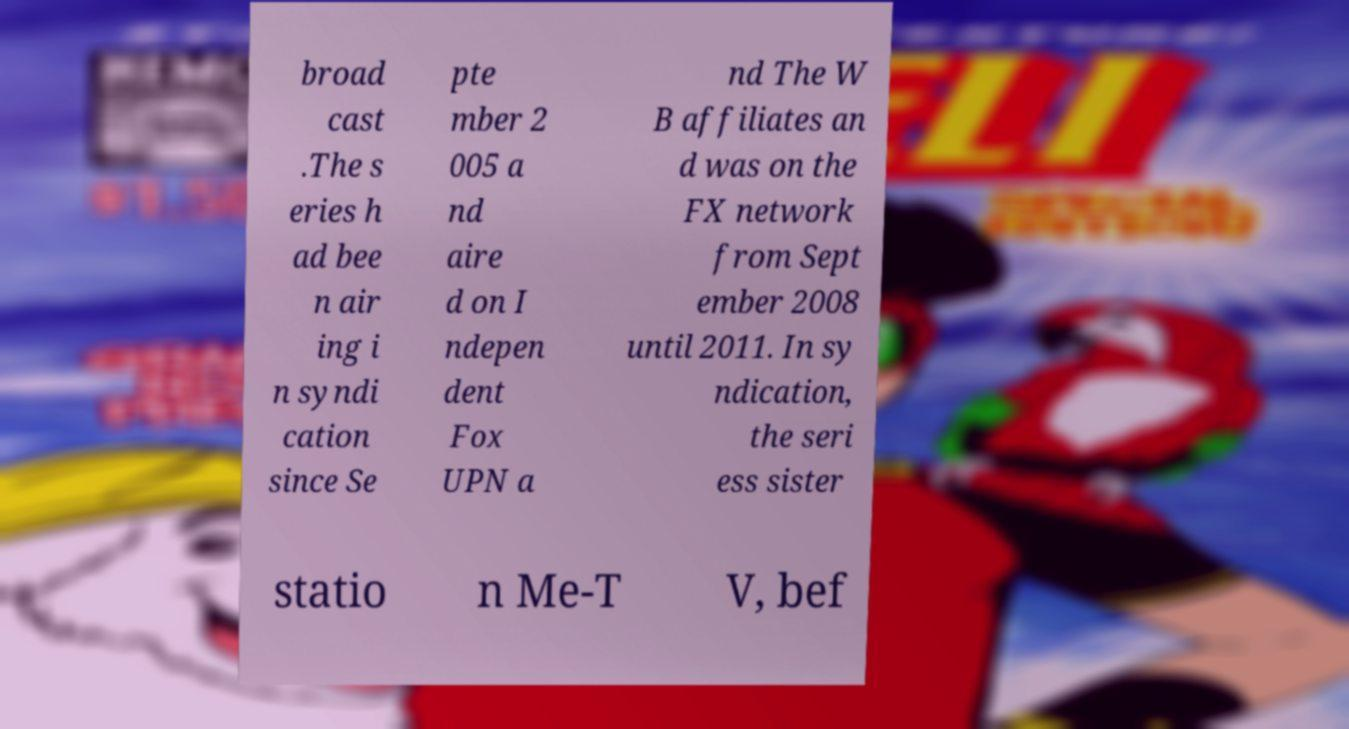Please read and relay the text visible in this image. What does it say? broad cast .The s eries h ad bee n air ing i n syndi cation since Se pte mber 2 005 a nd aire d on I ndepen dent Fox UPN a nd The W B affiliates an d was on the FX network from Sept ember 2008 until 2011. In sy ndication, the seri ess sister statio n Me-T V, bef 